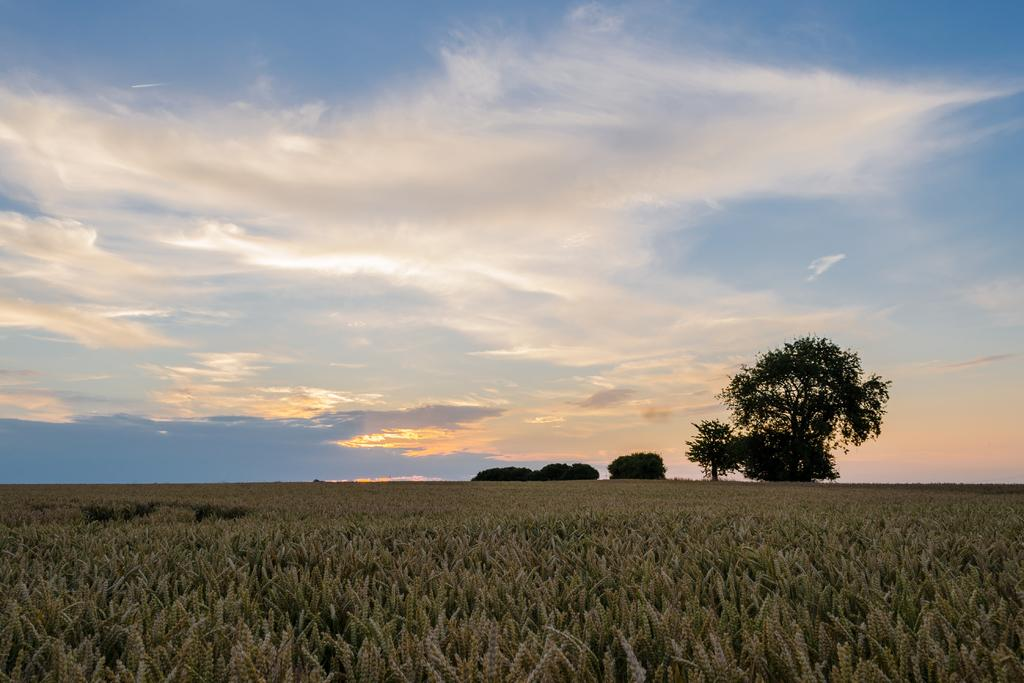What type of vegetation is present in the image? There are trees and plants in the image. What can be seen in the background of the image? The background of the image includes a cloudy sky. How many trucks are visible in the image? There are no trucks present in the image. What type of animal can be seen interacting with the plants in the image? There are no animals present in the image; it only features trees and plants. 